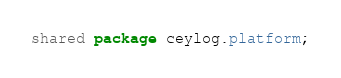Convert code to text. <code><loc_0><loc_0><loc_500><loc_500><_Ceylon_>shared package ceylog.platform;
</code> 